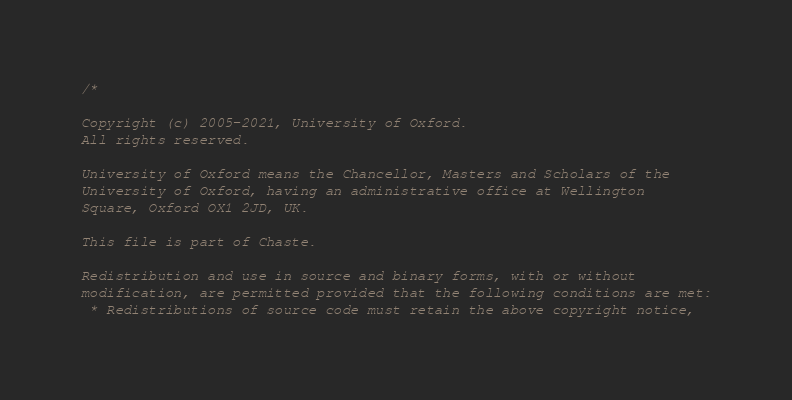<code> <loc_0><loc_0><loc_500><loc_500><_C++_>/*

Copyright (c) 2005-2021, University of Oxford.
All rights reserved.

University of Oxford means the Chancellor, Masters and Scholars of the
University of Oxford, having an administrative office at Wellington
Square, Oxford OX1 2JD, UK.

This file is part of Chaste.

Redistribution and use in source and binary forms, with or without
modification, are permitted provided that the following conditions are met:
 * Redistributions of source code must retain the above copyright notice,</code> 